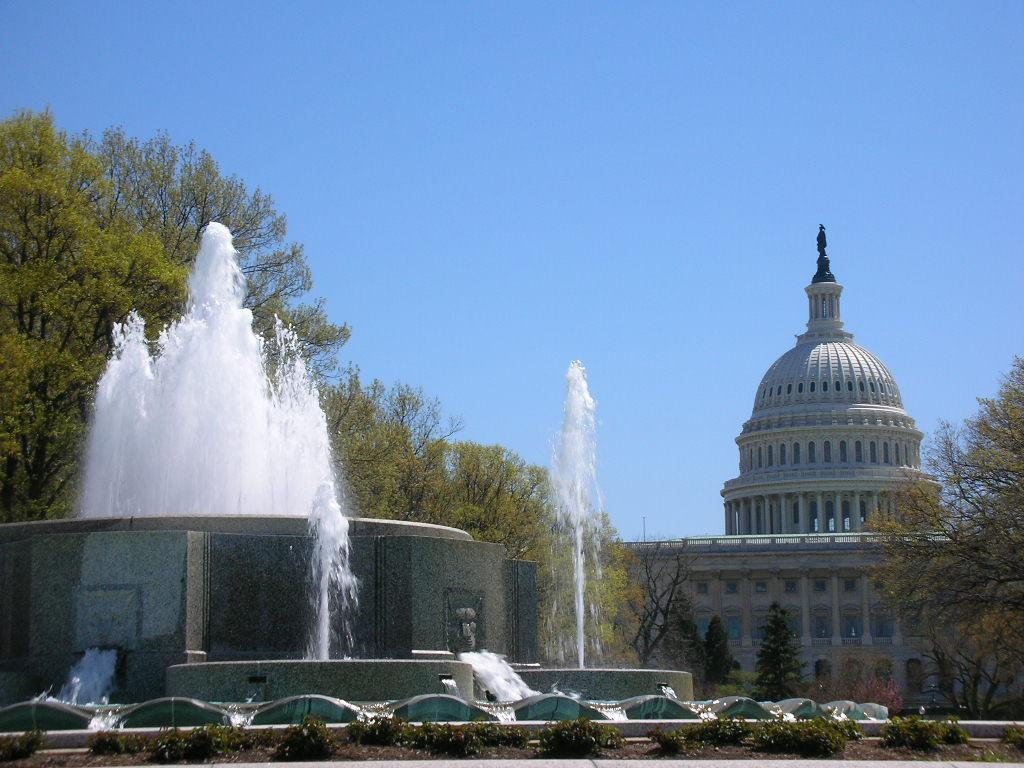What is the main feature of the image? There is a fountain in the image. What can be seen in the water in the image? There is no specific detail about the water in the image. What type of vegetation is present on the ground in the image? There are plants on the ground in the image. What other natural elements can be seen in the image? There are trees in the image. What type of structure is visible in the image? There is a building in the image. What is visible in the background of the image? The sky is visible in the image. How many flowers are present on the school building in the image? There is no school building or flowers present in the image. 